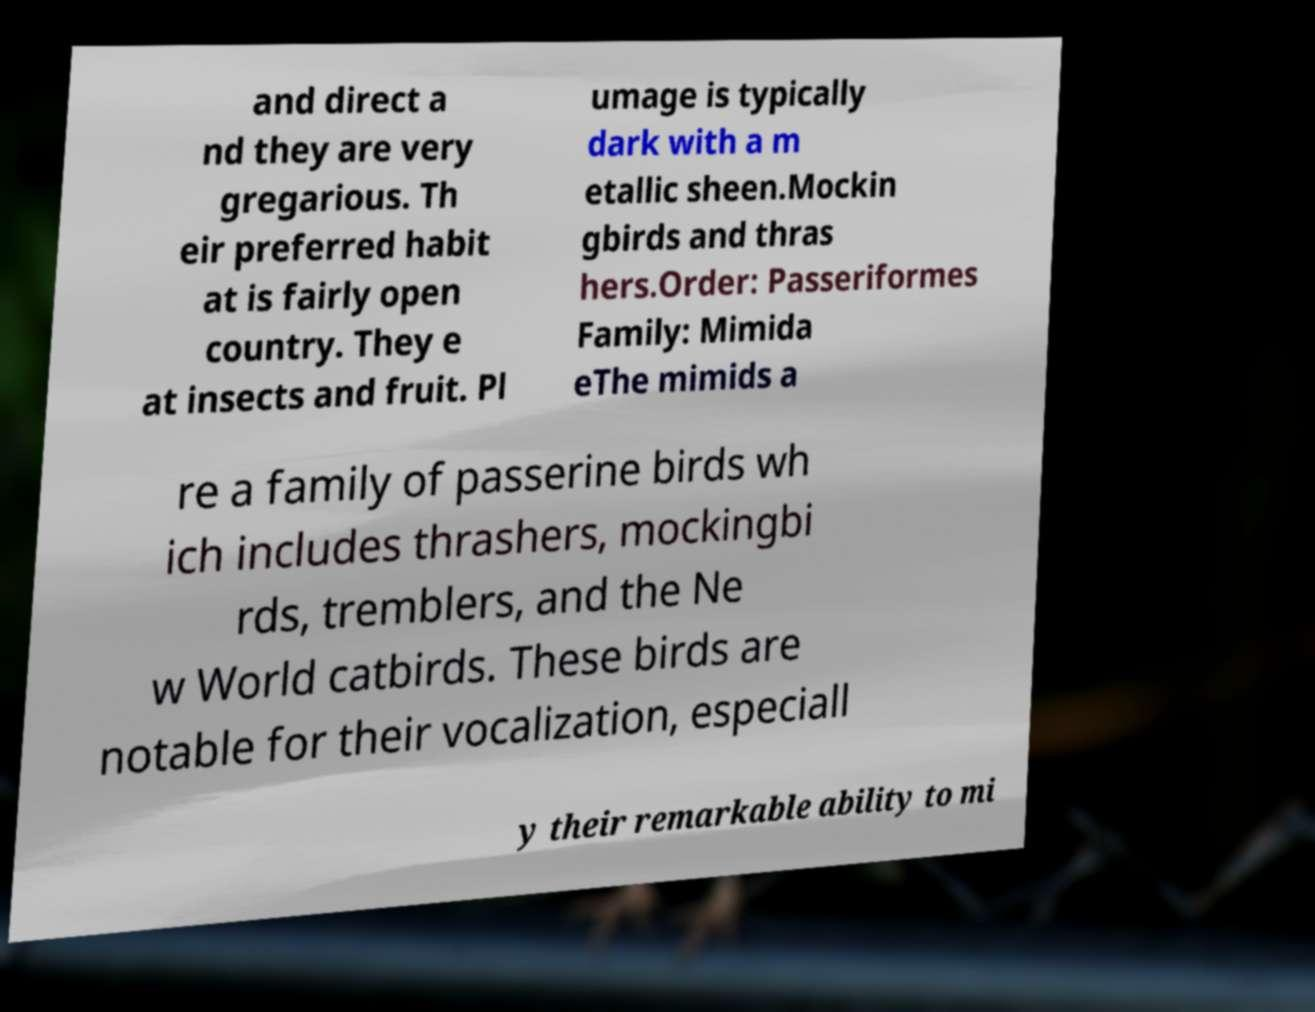Could you extract and type out the text from this image? and direct a nd they are very gregarious. Th eir preferred habit at is fairly open country. They e at insects and fruit. Pl umage is typically dark with a m etallic sheen.Mockin gbirds and thras hers.Order: Passeriformes Family: Mimida eThe mimids a re a family of passerine birds wh ich includes thrashers, mockingbi rds, tremblers, and the Ne w World catbirds. These birds are notable for their vocalization, especiall y their remarkable ability to mi 